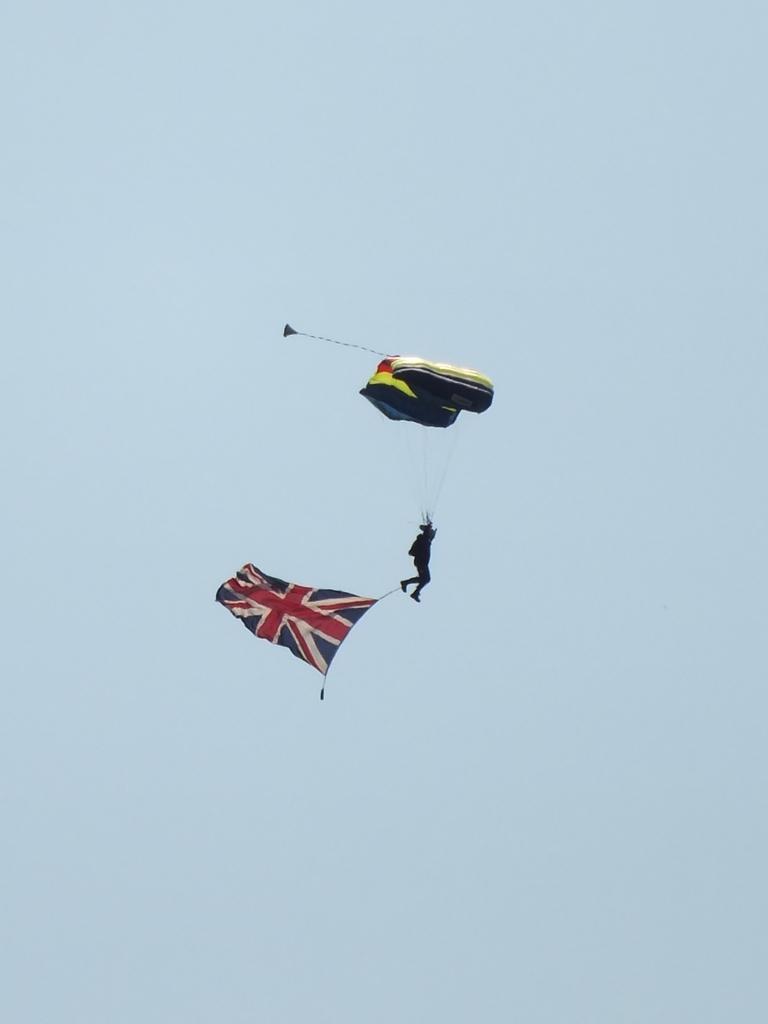Could you give a brief overview of what you see in this image? In this image we can see a person paragliding. We can also see the flag tied with a rope to his leg. On the backside we can see the sky which looks cloudy. 